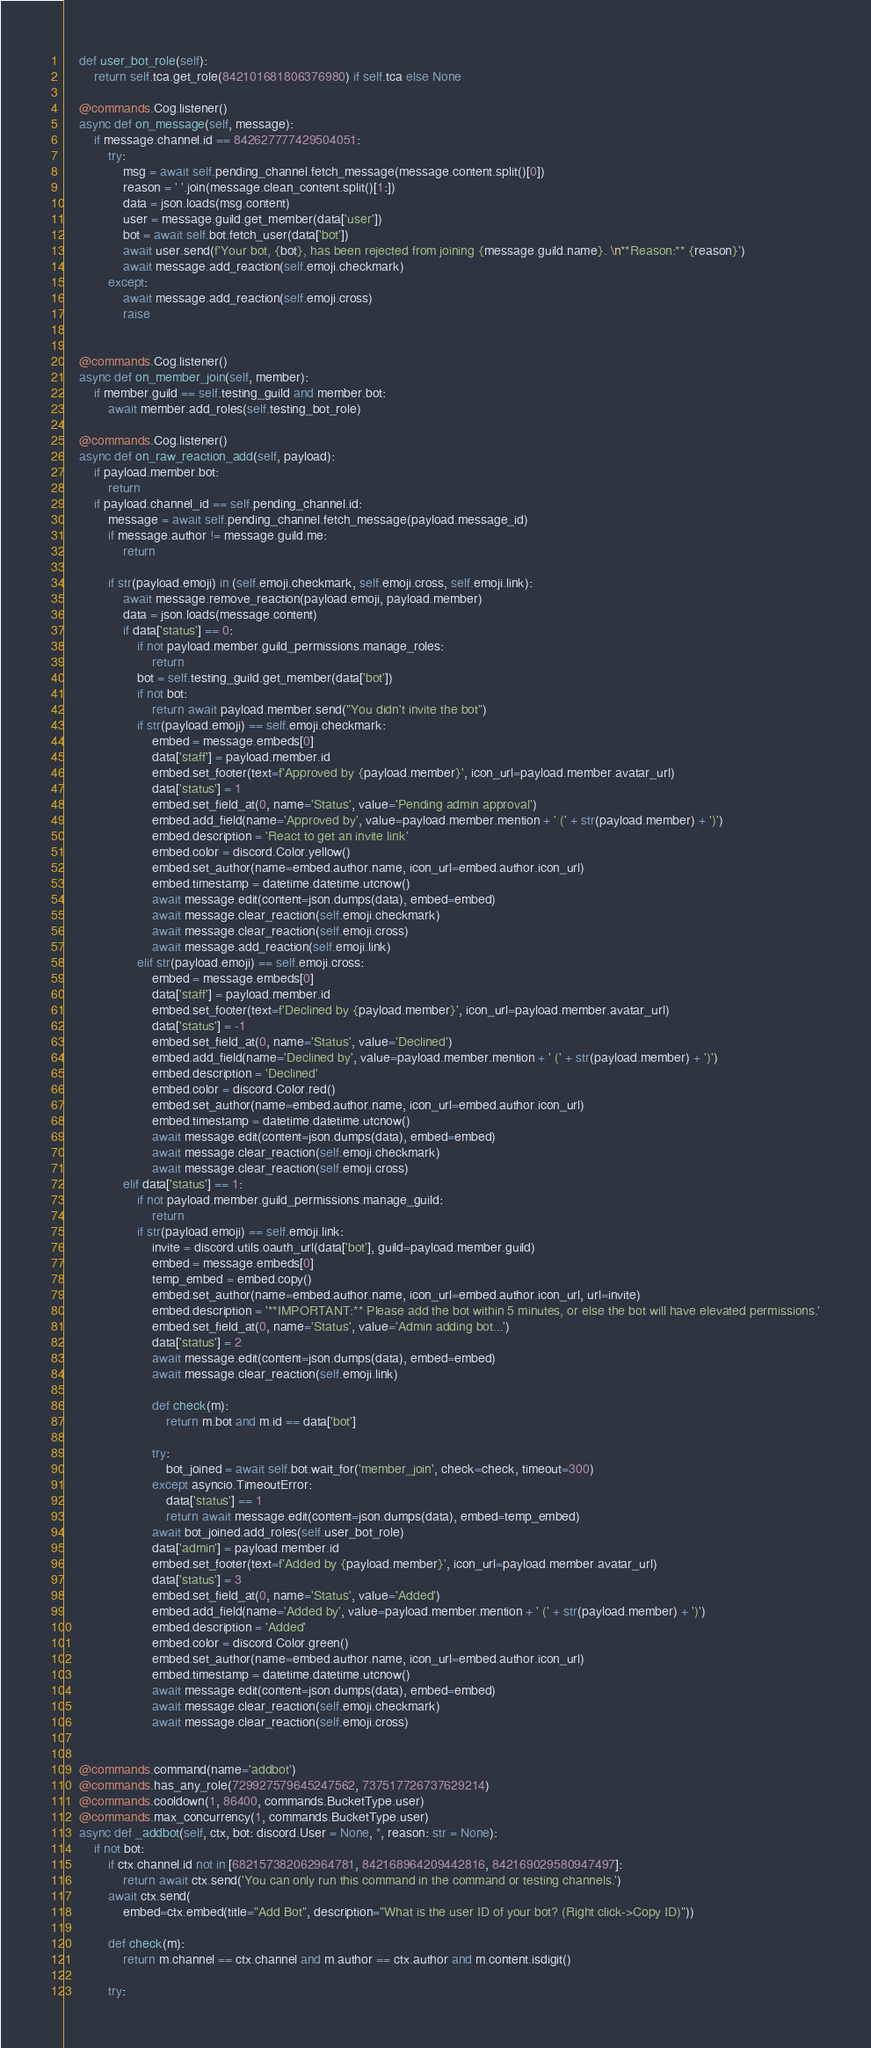Convert code to text. <code><loc_0><loc_0><loc_500><loc_500><_Python_>    def user_bot_role(self):
        return self.tca.get_role(842101681806376980) if self.tca else None
    
    @commands.Cog.listener()
    async def on_message(self, message):
        if message.channel.id == 842627777429504051:
            try:
                msg = await self.pending_channel.fetch_message(message.content.split()[0])
                reason = ' '.join(message.clean_content.split()[1:])
                data = json.loads(msg.content)
                user = message.guild.get_member(data['user'])
                bot = await self.bot.fetch_user(data['bot'])
                await user.send(f'Your bot, {bot}, has been rejected from joining {message.guild.name}. \n**Reason:** {reason}')
                await message.add_reaction(self.emoji.checkmark)
            except:
                await message.add_reaction(self.emoji.cross)
                raise
            

    @commands.Cog.listener()
    async def on_member_join(self, member):
        if member.guild == self.testing_guild and member.bot:
            await member.add_roles(self.testing_bot_role)

    @commands.Cog.listener()
    async def on_raw_reaction_add(self, payload):
        if payload.member.bot:
            return
        if payload.channel_id == self.pending_channel.id:
            message = await self.pending_channel.fetch_message(payload.message_id)
            if message.author != message.guild.me:
                return
            
            if str(payload.emoji) in (self.emoji.checkmark, self.emoji.cross, self.emoji.link):
                await message.remove_reaction(payload.emoji, payload.member)
                data = json.loads(message.content)
                if data['status'] == 0:
                    if not payload.member.guild_permissions.manage_roles:
                        return
                    bot = self.testing_guild.get_member(data['bot'])
                    if not bot:
                        return await payload.member.send("You didn't invite the bot")
                    if str(payload.emoji) == self.emoji.checkmark:
                        embed = message.embeds[0]
                        data['staff'] = payload.member.id
                        embed.set_footer(text=f'Approved by {payload.member}', icon_url=payload.member.avatar_url)
                        data['status'] = 1
                        embed.set_field_at(0, name='Status', value='Pending admin approval')
                        embed.add_field(name='Approved by', value=payload.member.mention + ' (' + str(payload.member) + ')')
                        embed.description = 'React to get an invite link'
                        embed.color = discord.Color.yellow()
                        embed.set_author(name=embed.author.name, icon_url=embed.author.icon_url)
                        embed.timestamp = datetime.datetime.utcnow()
                        await message.edit(content=json.dumps(data), embed=embed)
                        await message.clear_reaction(self.emoji.checkmark)
                        await message.clear_reaction(self.emoji.cross)
                        await message.add_reaction(self.emoji.link)
                    elif str(payload.emoji) == self.emoji.cross:
                        embed = message.embeds[0]
                        data['staff'] = payload.member.id
                        embed.set_footer(text=f'Declined by {payload.member}', icon_url=payload.member.avatar_url)
                        data['status'] = -1
                        embed.set_field_at(0, name='Status', value='Declined')
                        embed.add_field(name='Declined by', value=payload.member.mention + ' (' + str(payload.member) + ')')
                        embed.description = 'Declined'
                        embed.color = discord.Color.red()
                        embed.set_author(name=embed.author.name, icon_url=embed.author.icon_url)
                        embed.timestamp = datetime.datetime.utcnow()
                        await message.edit(content=json.dumps(data), embed=embed)
                        await message.clear_reaction(self.emoji.checkmark)
                        await message.clear_reaction(self.emoji.cross)
                elif data['status'] == 1:
                    if not payload.member.guild_permissions.manage_guild:
                        return
                    if str(payload.emoji) == self.emoji.link:
                        invite = discord.utils.oauth_url(data['bot'], guild=payload.member.guild)
                        embed = message.embeds[0]
                        temp_embed = embed.copy()
                        embed.set_author(name=embed.author.name, icon_url=embed.author.icon_url, url=invite)
                        embed.description = '**IMPORTANT:** Please add the bot within 5 minutes, or else the bot will have elevated permissions.'
                        embed.set_field_at(0, name='Status', value='Admin adding bot...')
                        data['status'] = 2
                        await message.edit(content=json.dumps(data), embed=embed)
                        await message.clear_reaction(self.emoji.link)
                        
                        def check(m):
                            return m.bot and m.id == data['bot']

                        try:
                            bot_joined = await self.bot.wait_for('member_join', check=check, timeout=300)
                        except asyncio.TimeoutError:
                            data['status'] == 1
                            return await message.edit(content=json.dumps(data), embed=temp_embed)
                        await bot_joined.add_roles(self.user_bot_role)
                        data['admin'] = payload.member.id
                        embed.set_footer(text=f'Added by {payload.member}', icon_url=payload.member.avatar_url)
                        data['status'] = 3
                        embed.set_field_at(0, name='Status', value='Added')
                        embed.add_field(name='Added by', value=payload.member.mention + ' (' + str(payload.member) + ')')
                        embed.description = 'Added'
                        embed.color = discord.Color.green()
                        embed.set_author(name=embed.author.name, icon_url=embed.author.icon_url)
                        embed.timestamp = datetime.datetime.utcnow()
                        await message.edit(content=json.dumps(data), embed=embed)
                        await message.clear_reaction(self.emoji.checkmark)
                        await message.clear_reaction(self.emoji.cross)


    @commands.command(name='addbot')
    @commands.has_any_role(729927579645247562, 737517726737629214)
    @commands.cooldown(1, 86400, commands.BucketType.user)
    @commands.max_concurrency(1, commands.BucketType.user)
    async def _addbot(self, ctx, bot: discord.User = None, *, reason: str = None):
        if not bot:
            if ctx.channel.id not in [682157382062964781, 842168964209442816, 842169029580947497]:
                return await ctx.send('You can only run this command in the command or testing channels.')
            await ctx.send(
                embed=ctx.embed(title="Add Bot", description="What is the user ID of your bot? (Right click->Copy ID)"))

            def check(m):
                return m.channel == ctx.channel and m.author == ctx.author and m.content.isdigit()

            try:</code> 